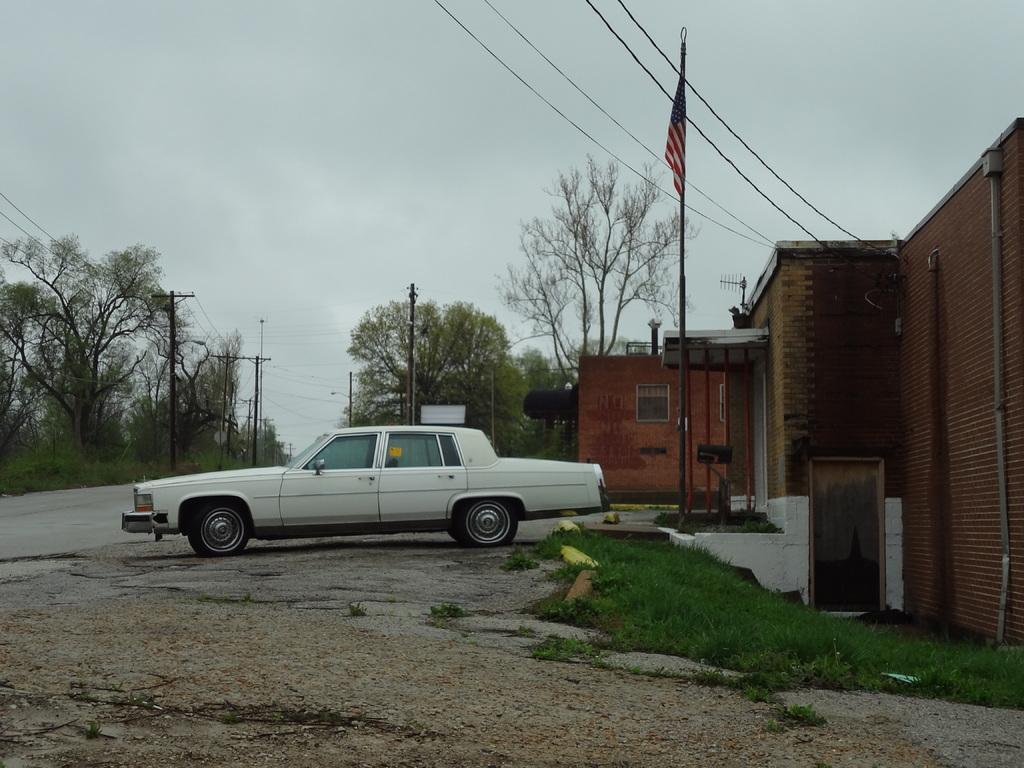Describe this image in one or two sentences. This image consists of a car in white color. At the bottom, there is a road. On the right, we can see green grass on the ground. And a building along with the door. In the middle, we can see a flag. In the background, there are trees. At the top, there is sky. 